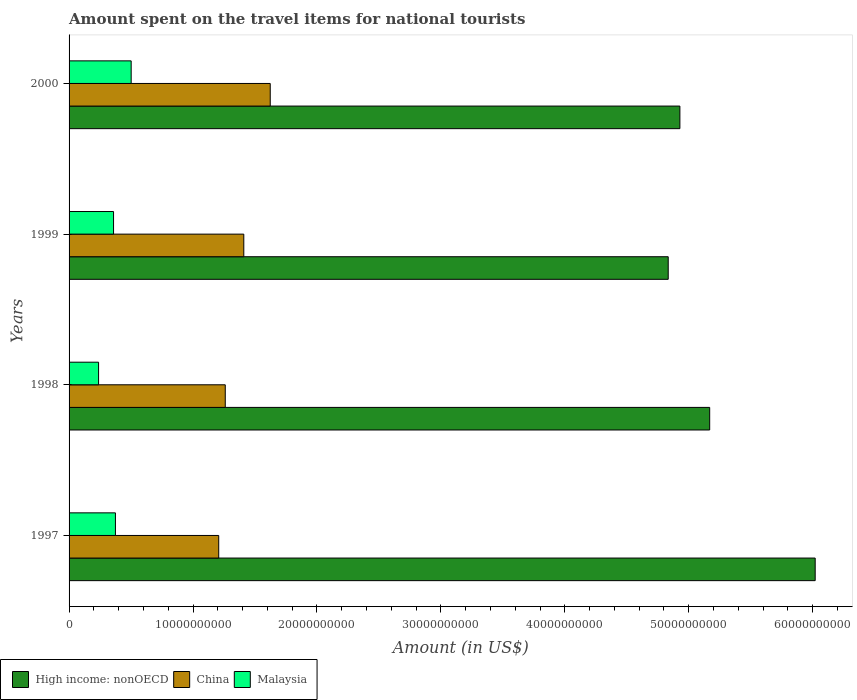How many bars are there on the 1st tick from the top?
Your response must be concise. 3. How many bars are there on the 2nd tick from the bottom?
Give a very brief answer. 3. In how many cases, is the number of bars for a given year not equal to the number of legend labels?
Offer a very short reply. 0. What is the amount spent on the travel items for national tourists in High income: nonOECD in 2000?
Your answer should be very brief. 4.93e+1. Across all years, what is the maximum amount spent on the travel items for national tourists in Malaysia?
Ensure brevity in your answer.  5.01e+09. Across all years, what is the minimum amount spent on the travel items for national tourists in High income: nonOECD?
Make the answer very short. 4.83e+1. What is the total amount spent on the travel items for national tourists in China in the graph?
Your response must be concise. 5.50e+1. What is the difference between the amount spent on the travel items for national tourists in High income: nonOECD in 1998 and that in 1999?
Keep it short and to the point. 3.35e+09. What is the difference between the amount spent on the travel items for national tourists in China in 2000 and the amount spent on the travel items for national tourists in Malaysia in 1997?
Your answer should be very brief. 1.25e+1. What is the average amount spent on the travel items for national tourists in China per year?
Your answer should be very brief. 1.38e+1. In the year 2000, what is the difference between the amount spent on the travel items for national tourists in Malaysia and amount spent on the travel items for national tourists in China?
Ensure brevity in your answer.  -1.12e+1. In how many years, is the amount spent on the travel items for national tourists in China greater than 36000000000 US$?
Your answer should be compact. 0. What is the ratio of the amount spent on the travel items for national tourists in Malaysia in 1997 to that in 1998?
Provide a succinct answer. 1.57. Is the amount spent on the travel items for national tourists in China in 1998 less than that in 1999?
Ensure brevity in your answer.  Yes. Is the difference between the amount spent on the travel items for national tourists in Malaysia in 1999 and 2000 greater than the difference between the amount spent on the travel items for national tourists in China in 1999 and 2000?
Your response must be concise. Yes. What is the difference between the highest and the second highest amount spent on the travel items for national tourists in Malaysia?
Ensure brevity in your answer.  1.27e+09. What is the difference between the highest and the lowest amount spent on the travel items for national tourists in Malaysia?
Your response must be concise. 2.63e+09. Is the sum of the amount spent on the travel items for national tourists in China in 1997 and 1998 greater than the maximum amount spent on the travel items for national tourists in High income: nonOECD across all years?
Make the answer very short. No. What does the 1st bar from the bottom in 2000 represents?
Your answer should be very brief. High income: nonOECD. What is the difference between two consecutive major ticks on the X-axis?
Provide a succinct answer. 1.00e+1. Does the graph contain grids?
Make the answer very short. No. Where does the legend appear in the graph?
Offer a very short reply. Bottom left. How many legend labels are there?
Your response must be concise. 3. How are the legend labels stacked?
Give a very brief answer. Horizontal. What is the title of the graph?
Offer a very short reply. Amount spent on the travel items for national tourists. Does "Botswana" appear as one of the legend labels in the graph?
Make the answer very short. No. What is the label or title of the Y-axis?
Your answer should be compact. Years. What is the Amount (in US$) of High income: nonOECD in 1997?
Provide a short and direct response. 6.02e+1. What is the Amount (in US$) of China in 1997?
Your answer should be very brief. 1.21e+1. What is the Amount (in US$) of Malaysia in 1997?
Offer a terse response. 3.74e+09. What is the Amount (in US$) of High income: nonOECD in 1998?
Ensure brevity in your answer.  5.17e+1. What is the Amount (in US$) of China in 1998?
Your answer should be very brief. 1.26e+1. What is the Amount (in US$) of Malaysia in 1998?
Keep it short and to the point. 2.38e+09. What is the Amount (in US$) in High income: nonOECD in 1999?
Your answer should be compact. 4.83e+1. What is the Amount (in US$) in China in 1999?
Offer a very short reply. 1.41e+1. What is the Amount (in US$) of Malaysia in 1999?
Your response must be concise. 3.59e+09. What is the Amount (in US$) of High income: nonOECD in 2000?
Offer a terse response. 4.93e+1. What is the Amount (in US$) in China in 2000?
Offer a terse response. 1.62e+1. What is the Amount (in US$) in Malaysia in 2000?
Provide a succinct answer. 5.01e+09. Across all years, what is the maximum Amount (in US$) of High income: nonOECD?
Your answer should be compact. 6.02e+1. Across all years, what is the maximum Amount (in US$) in China?
Your answer should be very brief. 1.62e+1. Across all years, what is the maximum Amount (in US$) in Malaysia?
Your answer should be compact. 5.01e+09. Across all years, what is the minimum Amount (in US$) in High income: nonOECD?
Offer a very short reply. 4.83e+1. Across all years, what is the minimum Amount (in US$) of China?
Give a very brief answer. 1.21e+1. Across all years, what is the minimum Amount (in US$) in Malaysia?
Your answer should be compact. 2.38e+09. What is the total Amount (in US$) of High income: nonOECD in the graph?
Provide a short and direct response. 2.10e+11. What is the total Amount (in US$) of China in the graph?
Offer a very short reply. 5.50e+1. What is the total Amount (in US$) in Malaysia in the graph?
Provide a succinct answer. 1.47e+1. What is the difference between the Amount (in US$) in High income: nonOECD in 1997 and that in 1998?
Provide a succinct answer. 8.51e+09. What is the difference between the Amount (in US$) of China in 1997 and that in 1998?
Your answer should be very brief. -5.28e+08. What is the difference between the Amount (in US$) of Malaysia in 1997 and that in 1998?
Your response must be concise. 1.36e+09. What is the difference between the Amount (in US$) of High income: nonOECD in 1997 and that in 1999?
Your response must be concise. 1.19e+1. What is the difference between the Amount (in US$) of China in 1997 and that in 1999?
Your answer should be compact. -2.02e+09. What is the difference between the Amount (in US$) in Malaysia in 1997 and that in 1999?
Your answer should be very brief. 1.53e+08. What is the difference between the Amount (in US$) of High income: nonOECD in 1997 and that in 2000?
Your answer should be very brief. 1.09e+1. What is the difference between the Amount (in US$) in China in 1997 and that in 2000?
Offer a very short reply. -4.16e+09. What is the difference between the Amount (in US$) of Malaysia in 1997 and that in 2000?
Offer a terse response. -1.27e+09. What is the difference between the Amount (in US$) in High income: nonOECD in 1998 and that in 1999?
Make the answer very short. 3.35e+09. What is the difference between the Amount (in US$) in China in 1998 and that in 1999?
Make the answer very short. -1.50e+09. What is the difference between the Amount (in US$) in Malaysia in 1998 and that in 1999?
Make the answer very short. -1.21e+09. What is the difference between the Amount (in US$) in High income: nonOECD in 1998 and that in 2000?
Offer a terse response. 2.40e+09. What is the difference between the Amount (in US$) in China in 1998 and that in 2000?
Your response must be concise. -3.63e+09. What is the difference between the Amount (in US$) in Malaysia in 1998 and that in 2000?
Provide a short and direct response. -2.63e+09. What is the difference between the Amount (in US$) in High income: nonOECD in 1999 and that in 2000?
Keep it short and to the point. -9.42e+08. What is the difference between the Amount (in US$) in China in 1999 and that in 2000?
Ensure brevity in your answer.  -2.13e+09. What is the difference between the Amount (in US$) of Malaysia in 1999 and that in 2000?
Offer a terse response. -1.42e+09. What is the difference between the Amount (in US$) in High income: nonOECD in 1997 and the Amount (in US$) in China in 1998?
Keep it short and to the point. 4.76e+1. What is the difference between the Amount (in US$) in High income: nonOECD in 1997 and the Amount (in US$) in Malaysia in 1998?
Keep it short and to the point. 5.78e+1. What is the difference between the Amount (in US$) of China in 1997 and the Amount (in US$) of Malaysia in 1998?
Provide a succinct answer. 9.69e+09. What is the difference between the Amount (in US$) of High income: nonOECD in 1997 and the Amount (in US$) of China in 1999?
Your response must be concise. 4.61e+1. What is the difference between the Amount (in US$) of High income: nonOECD in 1997 and the Amount (in US$) of Malaysia in 1999?
Provide a succinct answer. 5.66e+1. What is the difference between the Amount (in US$) in China in 1997 and the Amount (in US$) in Malaysia in 1999?
Make the answer very short. 8.49e+09. What is the difference between the Amount (in US$) of High income: nonOECD in 1997 and the Amount (in US$) of China in 2000?
Your response must be concise. 4.40e+1. What is the difference between the Amount (in US$) of High income: nonOECD in 1997 and the Amount (in US$) of Malaysia in 2000?
Make the answer very short. 5.52e+1. What is the difference between the Amount (in US$) of China in 1997 and the Amount (in US$) of Malaysia in 2000?
Your answer should be very brief. 7.06e+09. What is the difference between the Amount (in US$) in High income: nonOECD in 1998 and the Amount (in US$) in China in 1999?
Offer a very short reply. 3.76e+1. What is the difference between the Amount (in US$) of High income: nonOECD in 1998 and the Amount (in US$) of Malaysia in 1999?
Keep it short and to the point. 4.81e+1. What is the difference between the Amount (in US$) in China in 1998 and the Amount (in US$) in Malaysia in 1999?
Your answer should be compact. 9.01e+09. What is the difference between the Amount (in US$) of High income: nonOECD in 1998 and the Amount (in US$) of China in 2000?
Offer a very short reply. 3.55e+1. What is the difference between the Amount (in US$) of High income: nonOECD in 1998 and the Amount (in US$) of Malaysia in 2000?
Your answer should be very brief. 4.67e+1. What is the difference between the Amount (in US$) of China in 1998 and the Amount (in US$) of Malaysia in 2000?
Keep it short and to the point. 7.59e+09. What is the difference between the Amount (in US$) of High income: nonOECD in 1999 and the Amount (in US$) of China in 2000?
Provide a succinct answer. 3.21e+1. What is the difference between the Amount (in US$) in High income: nonOECD in 1999 and the Amount (in US$) in Malaysia in 2000?
Provide a short and direct response. 4.33e+1. What is the difference between the Amount (in US$) in China in 1999 and the Amount (in US$) in Malaysia in 2000?
Give a very brief answer. 9.09e+09. What is the average Amount (in US$) in High income: nonOECD per year?
Your answer should be compact. 5.24e+1. What is the average Amount (in US$) in China per year?
Your response must be concise. 1.38e+1. What is the average Amount (in US$) in Malaysia per year?
Offer a terse response. 3.68e+09. In the year 1997, what is the difference between the Amount (in US$) of High income: nonOECD and Amount (in US$) of China?
Your answer should be very brief. 4.81e+1. In the year 1997, what is the difference between the Amount (in US$) of High income: nonOECD and Amount (in US$) of Malaysia?
Provide a succinct answer. 5.65e+1. In the year 1997, what is the difference between the Amount (in US$) in China and Amount (in US$) in Malaysia?
Make the answer very short. 8.33e+09. In the year 1998, what is the difference between the Amount (in US$) in High income: nonOECD and Amount (in US$) in China?
Your answer should be very brief. 3.91e+1. In the year 1998, what is the difference between the Amount (in US$) in High income: nonOECD and Amount (in US$) in Malaysia?
Make the answer very short. 4.93e+1. In the year 1998, what is the difference between the Amount (in US$) of China and Amount (in US$) of Malaysia?
Your answer should be compact. 1.02e+1. In the year 1999, what is the difference between the Amount (in US$) in High income: nonOECD and Amount (in US$) in China?
Keep it short and to the point. 3.42e+1. In the year 1999, what is the difference between the Amount (in US$) of High income: nonOECD and Amount (in US$) of Malaysia?
Your answer should be compact. 4.48e+1. In the year 1999, what is the difference between the Amount (in US$) in China and Amount (in US$) in Malaysia?
Your response must be concise. 1.05e+1. In the year 2000, what is the difference between the Amount (in US$) in High income: nonOECD and Amount (in US$) in China?
Your answer should be compact. 3.31e+1. In the year 2000, what is the difference between the Amount (in US$) in High income: nonOECD and Amount (in US$) in Malaysia?
Give a very brief answer. 4.43e+1. In the year 2000, what is the difference between the Amount (in US$) in China and Amount (in US$) in Malaysia?
Offer a very short reply. 1.12e+1. What is the ratio of the Amount (in US$) in High income: nonOECD in 1997 to that in 1998?
Provide a short and direct response. 1.16. What is the ratio of the Amount (in US$) in China in 1997 to that in 1998?
Provide a short and direct response. 0.96. What is the ratio of the Amount (in US$) in Malaysia in 1997 to that in 1998?
Your response must be concise. 1.57. What is the ratio of the Amount (in US$) of High income: nonOECD in 1997 to that in 1999?
Keep it short and to the point. 1.25. What is the ratio of the Amount (in US$) of China in 1997 to that in 1999?
Offer a very short reply. 0.86. What is the ratio of the Amount (in US$) of Malaysia in 1997 to that in 1999?
Ensure brevity in your answer.  1.04. What is the ratio of the Amount (in US$) of High income: nonOECD in 1997 to that in 2000?
Give a very brief answer. 1.22. What is the ratio of the Amount (in US$) of China in 1997 to that in 2000?
Provide a succinct answer. 0.74. What is the ratio of the Amount (in US$) of Malaysia in 1997 to that in 2000?
Your answer should be compact. 0.75. What is the ratio of the Amount (in US$) of High income: nonOECD in 1998 to that in 1999?
Offer a very short reply. 1.07. What is the ratio of the Amount (in US$) of China in 1998 to that in 1999?
Ensure brevity in your answer.  0.89. What is the ratio of the Amount (in US$) of Malaysia in 1998 to that in 1999?
Make the answer very short. 0.66. What is the ratio of the Amount (in US$) in High income: nonOECD in 1998 to that in 2000?
Offer a terse response. 1.05. What is the ratio of the Amount (in US$) of China in 1998 to that in 2000?
Your answer should be compact. 0.78. What is the ratio of the Amount (in US$) in Malaysia in 1998 to that in 2000?
Provide a short and direct response. 0.48. What is the ratio of the Amount (in US$) in High income: nonOECD in 1999 to that in 2000?
Ensure brevity in your answer.  0.98. What is the ratio of the Amount (in US$) in China in 1999 to that in 2000?
Offer a very short reply. 0.87. What is the ratio of the Amount (in US$) of Malaysia in 1999 to that in 2000?
Offer a terse response. 0.72. What is the difference between the highest and the second highest Amount (in US$) of High income: nonOECD?
Offer a very short reply. 8.51e+09. What is the difference between the highest and the second highest Amount (in US$) of China?
Keep it short and to the point. 2.13e+09. What is the difference between the highest and the second highest Amount (in US$) of Malaysia?
Provide a succinct answer. 1.27e+09. What is the difference between the highest and the lowest Amount (in US$) in High income: nonOECD?
Your response must be concise. 1.19e+1. What is the difference between the highest and the lowest Amount (in US$) in China?
Give a very brief answer. 4.16e+09. What is the difference between the highest and the lowest Amount (in US$) of Malaysia?
Your answer should be very brief. 2.63e+09. 